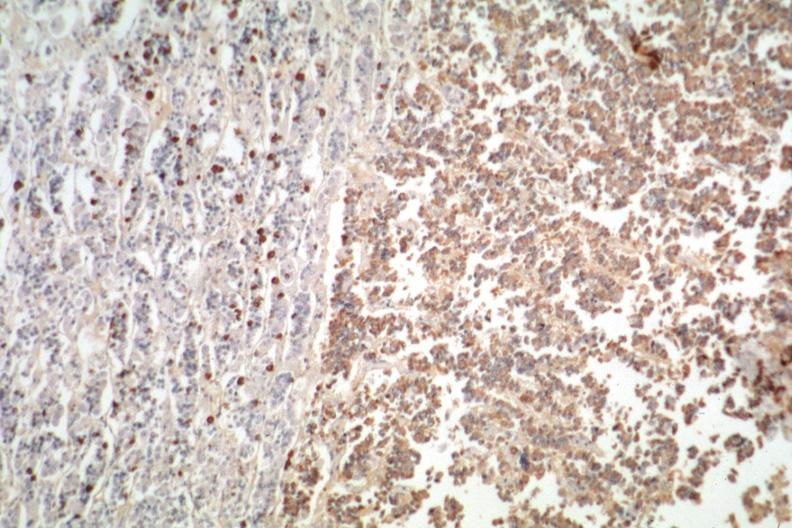s omentum present?
Answer the question using a single word or phrase. No 